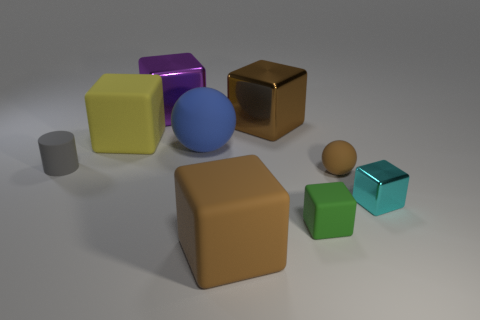Are there any other things that have the same size as the gray object?
Ensure brevity in your answer.  Yes. There is a big yellow rubber object; are there any rubber cubes in front of it?
Offer a terse response. Yes. What is the color of the metal cube behind the large metallic cube that is on the right side of the large metal thing on the left side of the large brown shiny cube?
Make the answer very short. Purple. What is the shape of the gray matte object that is the same size as the cyan block?
Provide a succinct answer. Cylinder. Are there more big green balls than brown metallic cubes?
Ensure brevity in your answer.  No. Are there any green matte objects that are on the left side of the large metallic object to the right of the big purple shiny cube?
Offer a very short reply. No. There is another big matte thing that is the same shape as the yellow object; what color is it?
Your answer should be very brief. Brown. Is there anything else that has the same shape as the small green thing?
Offer a terse response. Yes. There is a tiny ball that is the same material as the large blue thing; what color is it?
Provide a succinct answer. Brown. There is a metallic block to the left of the large rubber block in front of the gray cylinder; are there any gray matte cylinders that are to the right of it?
Give a very brief answer. No. 